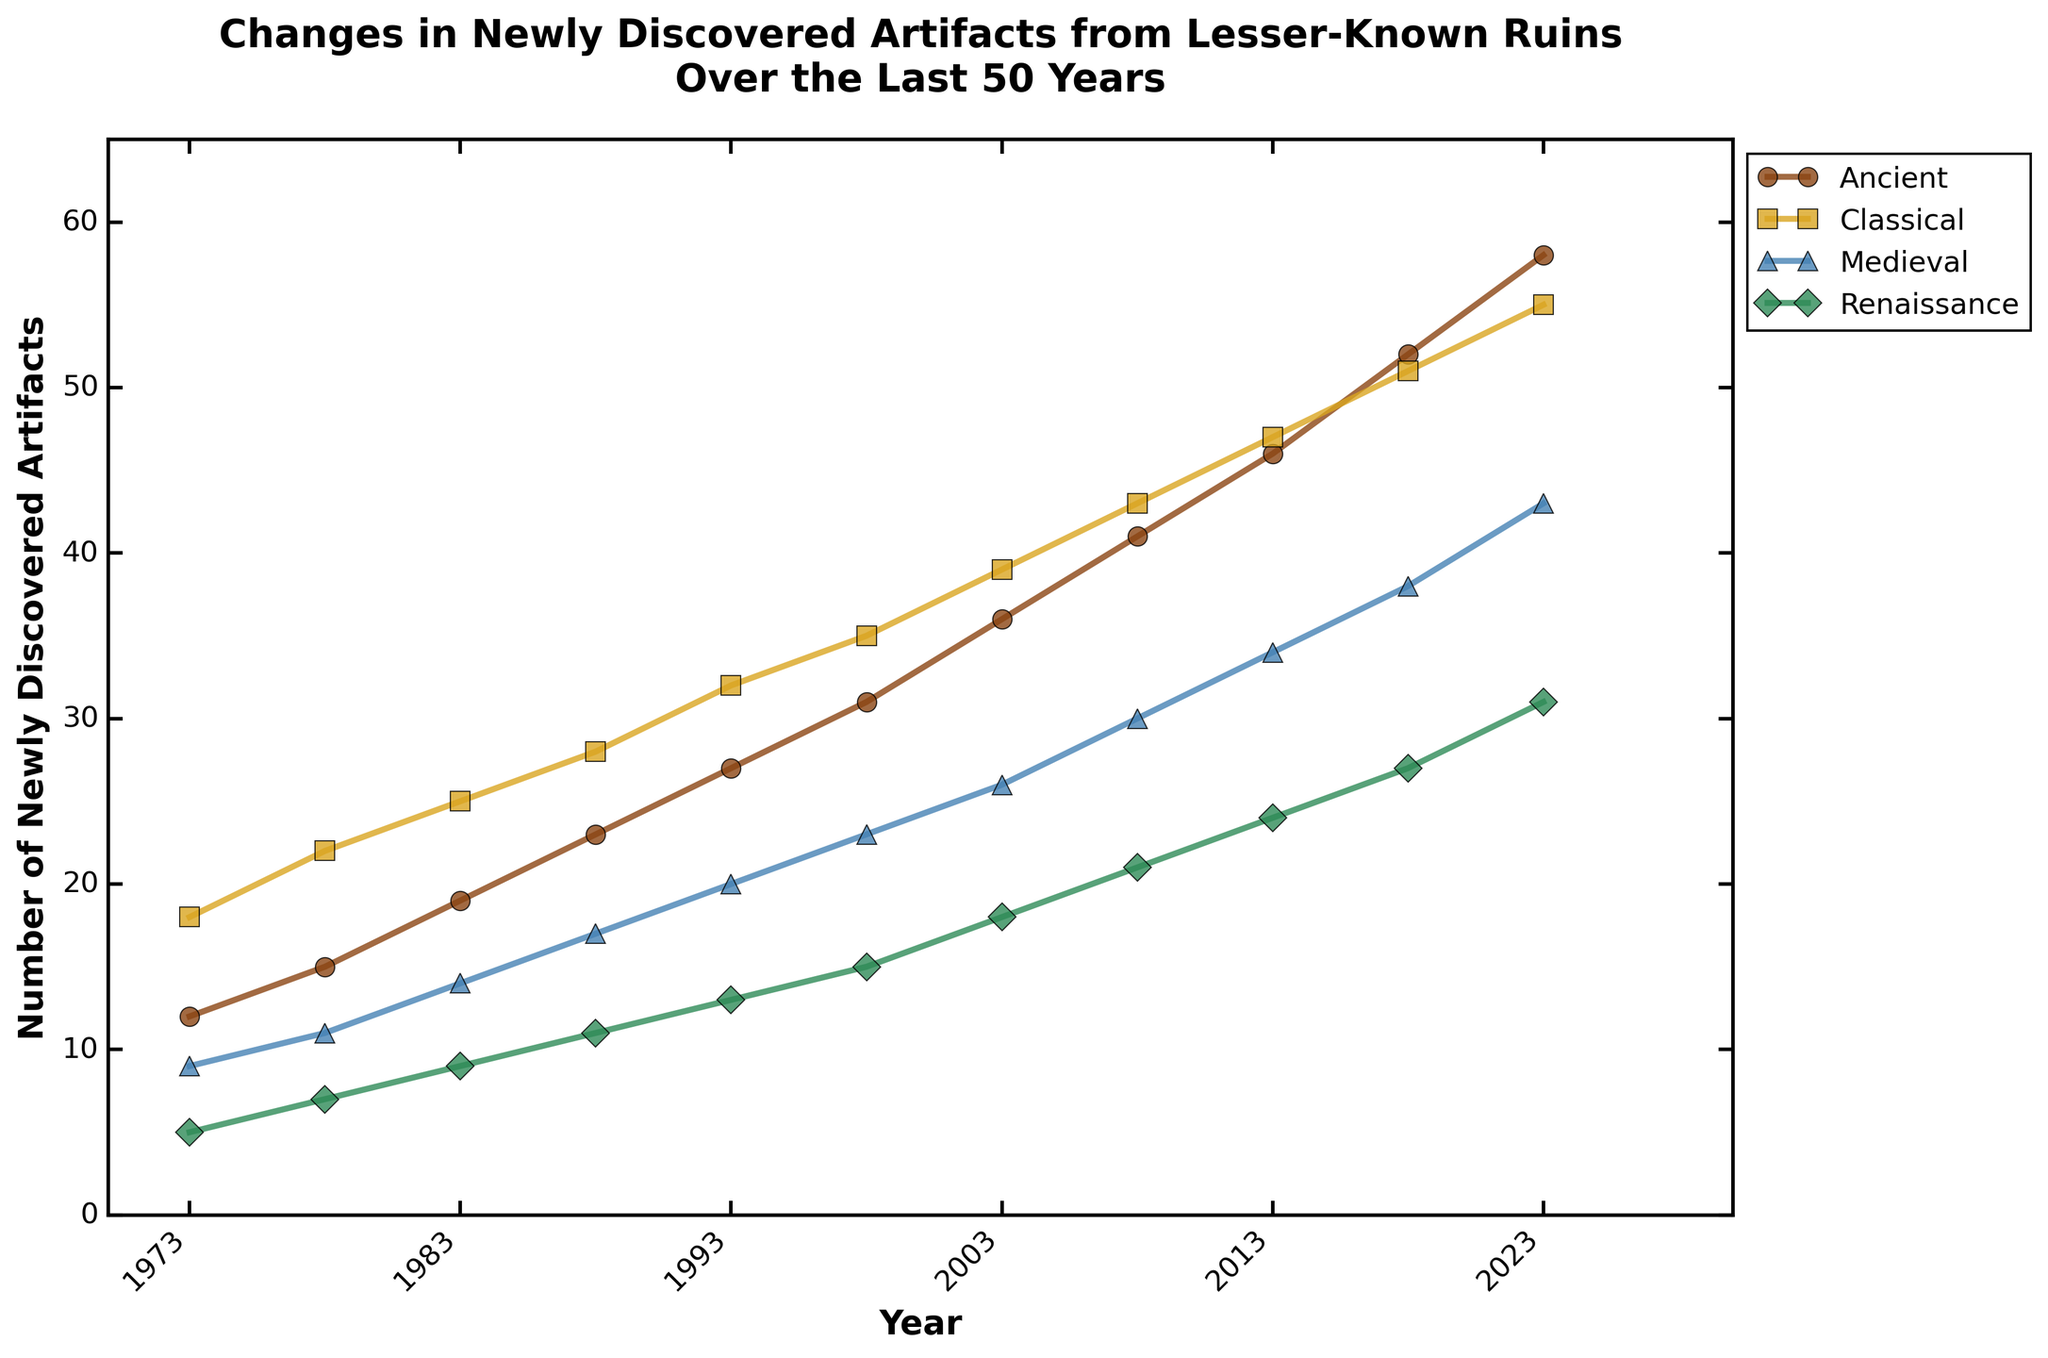Which historical period showed the highest number of newly discovered artifacts in the year 2023? To identify the highest number of newly discovered artifacts in 2023, check the data points for all historical periods in that year. The data shows: Ancient (58), Classical (55), Medieval (43), Renaissance (31). The Ancient period has the highest value of 58.
Answer: Ancient How did the number of newly discovered Medieval artifacts change from 1983 to 1993? Identify the values in 1983 and 1993 for the Medieval period from the chart. For 1983, it is 14, and for 1993, it is 20. Calculate the change: 20 - 14 = 6. The number of artifacts increased by 6.
Answer: Increased by 6 Which period had the steepest increase in newly discovered artifacts between 2013 and 2018? Examine the slopes of the lines between 2013 and 2018 for each period. The changes are: Ancient (52-46 = 6), Classical (51-47 = 4), Medieval (38-34 = 4), Renaissance (27-24 = 3). Calculate the increases and compare. The steepest increase is in the Ancient period, with a change of 6.
Answer: Ancient In which year did the Renaissance period first exceed 20 newly discovered artifacts? Review the values for the Renaissance period over the shown years and identify when it first exceeded 20. The Renaissance period went above 20 artifacts in 2008, with a count of 21.
Answer: 2008 What's the difference in the number of newly discovered artifacts between the Ancient and Renaissance periods in 2023? Compare the values for the Ancient (58) and Renaissance (31) periods in 2023. Subtract the Renaissance value from the Ancient value: 58 - 31 = 27.
Answer: 27 On average, how many artifacts were discovered yearly in the Classical period from 1973 to 2023? Calculate the average over the years shown for the Classical period. Sum the values: 18+22+25+28+32+35+39+43+47+51+55 = 395. Count the years (11). Divide the sum by the number of years: 395 / 11 = 35.91.
Answer: 35.91 Which period had the smallest number of discoveries in 1973, and what was that number? Review the values for all periods in 1973. The data points are: Ancient (12), Classical (18), Medieval (9), Renaissance (5). The smallest number of discoveries is in the Renaissance period with 5.
Answer: Renaissance, 5 Did the number of discoveries in the Medieval period ever surpass those in the Classical period over the 50 years? Compare the values of discoveries for the Medieval and Classical periods across all the years. The Medieval values never exceeded the Classical values in any of the years shown.
Answer: No How does the rate of increase in discoveries compare between the Ancient and Medieval periods from 1998 to 2003? Calculate the rate of increase for both periods from 1998 to 2003. For Ancient: (36-31)/5 = 1. For Medieval: (26-23)/5 = 0.6. The rate of increase is 1 per year for Ancient and 0.6 per year for Medieval.
Answer: Ancient increased faster By how much did the total number of newly discovered Renaissance artifacts increase between 1973 and 2023? Compare the Renaissance values in 1973 (5) and 2023 (31). Calculate the increase: 31 - 5 = 26. The total number increased by 26.
Answer: 26 